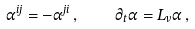<formula> <loc_0><loc_0><loc_500><loc_500>\alpha ^ { i j } = - \alpha ^ { j i } \, , \quad \partial _ { t } \alpha = L _ { v } \alpha \, ,</formula> 